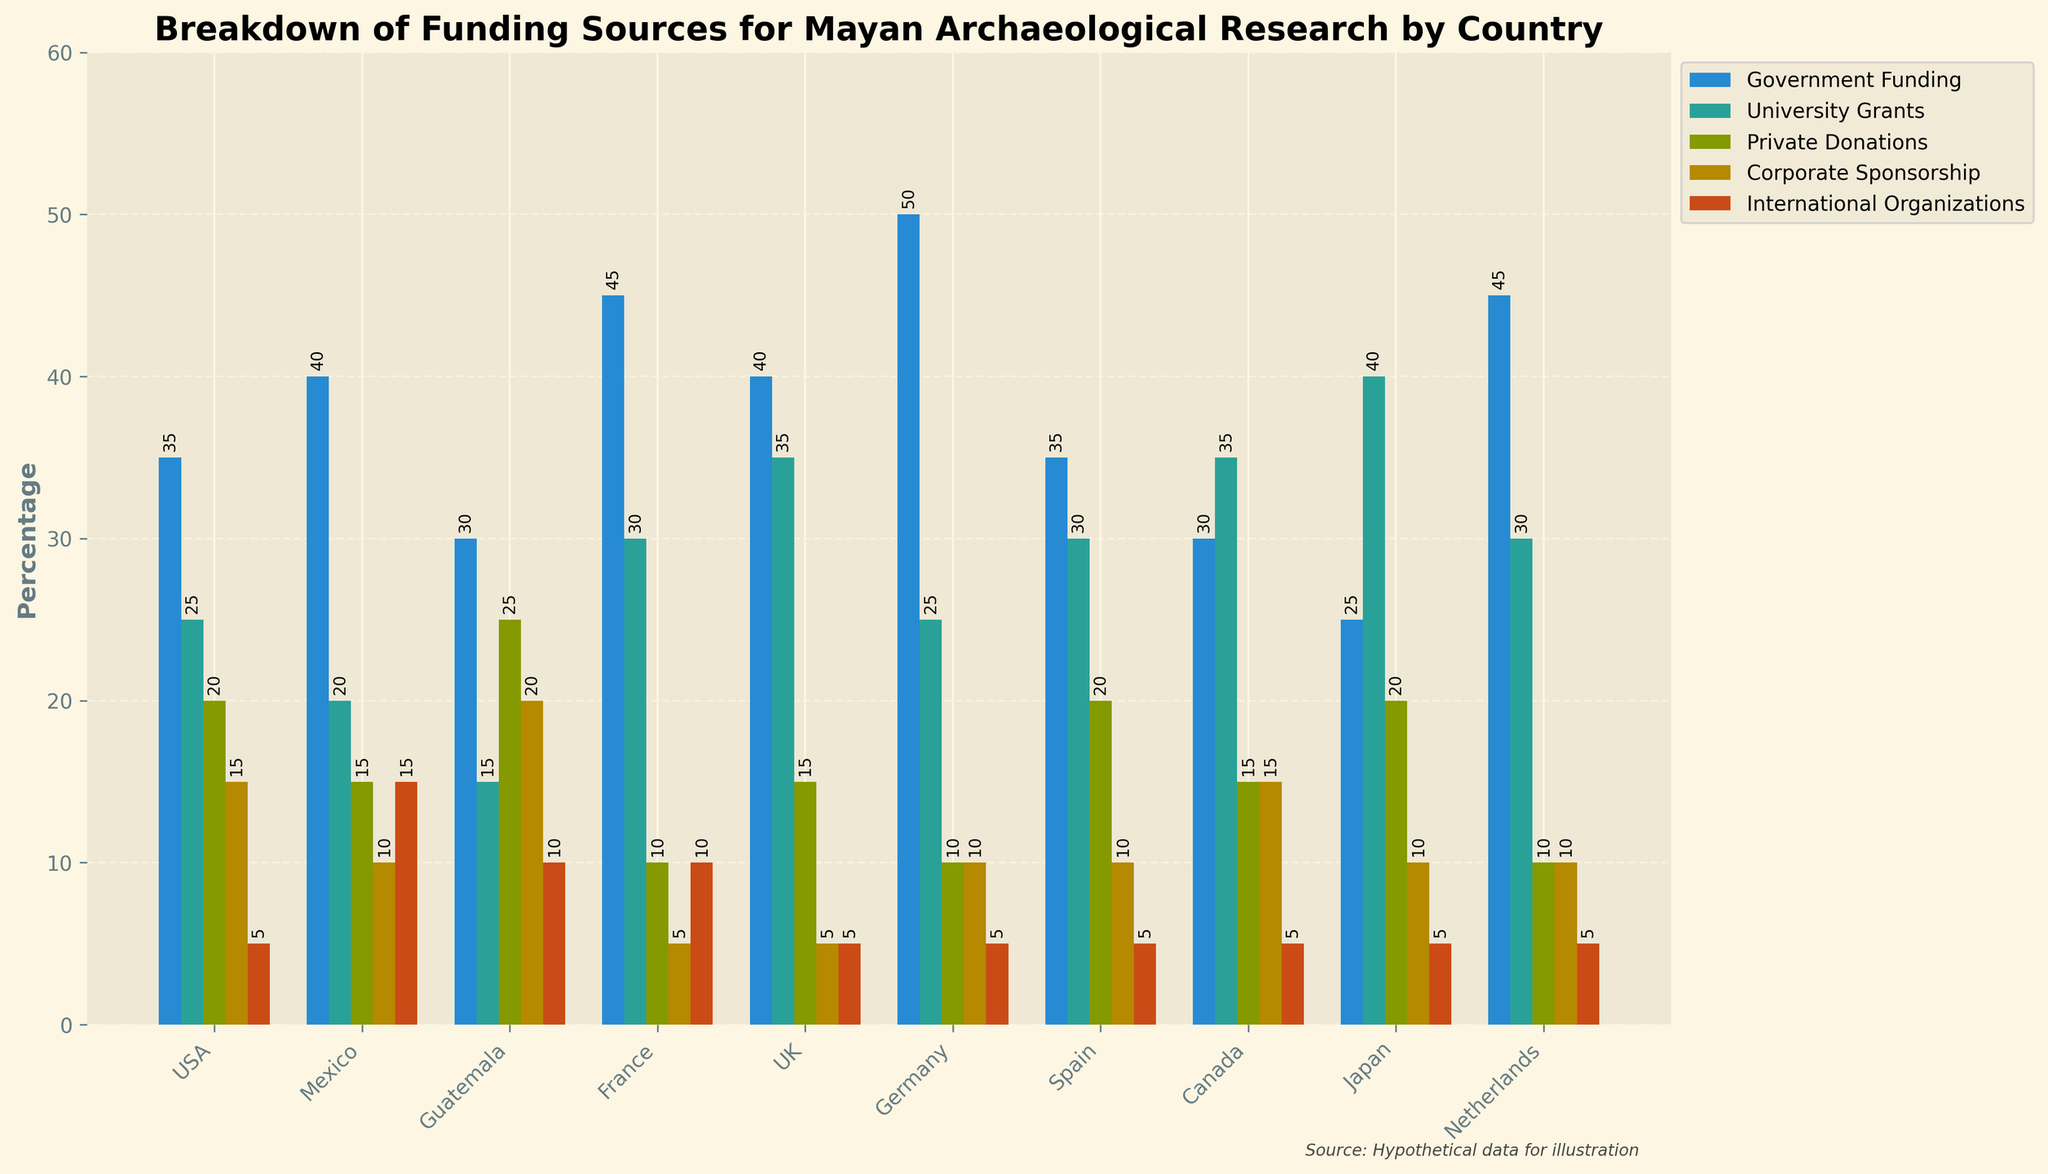Which country receives the highest percentage of government funding? By looking at the heights of the bars representing government funding, Germany has the tallest bar, indicating the highest percentage.
Answer: Germany How does the percentage of university grants in Japan compare to that in France? The bar for university grants in Japan is at 40%, whilst the bar in France is at 30%. Thus, Japan has a higher percentage.
Answer: Japan has a higher percentage What is the difference between the private donations percentages of Spain and Guatemala? Spain has a 20% private donations bar and Guatemala has a 25% one. The difference is 25% - 20% = 5%.
Answer: 5% Which countries receive at least 30% in government funding? By scanning the heights of the bars across countries for government funding above 30%, USA, Mexico, Guatemala, France, UK, Germany, Spain, and the Netherlands meet this criterion.
Answer: USA, Mexico, Guatemala, France, UK, Germany, Spain, Netherlands Among the sources of funding for the UK, which one has the smallest contribution? By observing the heights of bars for the UK, corporate sponsorship and international organizations are each at 5%.
Answer: Corporate Sponsorship and International Organizations What is the average percentage of private donations across all countries? The percentages for private donations are: 20%, 15%, 25%, 10%, 15%, 10%, 20%, 15%, 20%, 10%. Sum is 160%, divided by 10 countries, the average is 16%.
Answer: 16% Is there a country that receives an equal percentage of corporate sponsorship and international organizations funding? By observing the lengths of bars, both Mexico (10%) and Guatemala (10%) have equal proportions in these funding categories.
Answer: Mexico, Guatemala Which country has the highest percentage difference between government funding and university grants? Calculating the difference for each country, Germany (50% - 25% = 25%) shows the highest difference.
Answer: Germany What is the total percentage of funding from international organizations for European countries? Summing international organization percentages for France (10%), UK (5%), Germany (5%), Spain (5%), Netherlands (5%) gives 30%.
Answer: 30% What visual clue indicates the category with minimal participation by international organizations? All international organizations bars are fairly short, especially for USA, UK, Germany, Spain, Japan, Netherlands which are at 5%, indicating minimal participation.
Answer: Short bars 